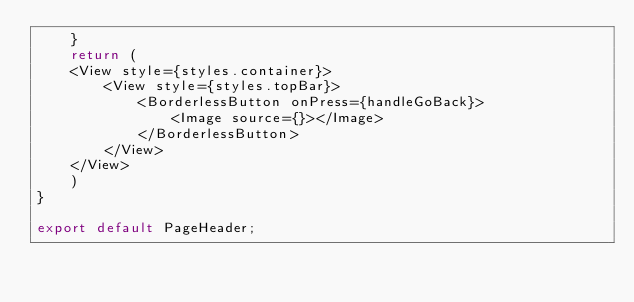<code> <loc_0><loc_0><loc_500><loc_500><_TypeScript_>    }
    return (
    <View style={styles.container}>
        <View style={styles.topBar}>
            <BorderlessButton onPress={handleGoBack}>
                <Image source={}></Image>
            </BorderlessButton>
        </View>
    </View>
    )
}

export default PageHeader;</code> 